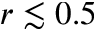<formula> <loc_0><loc_0><loc_500><loc_500>r \lesssim 0 . 5</formula> 